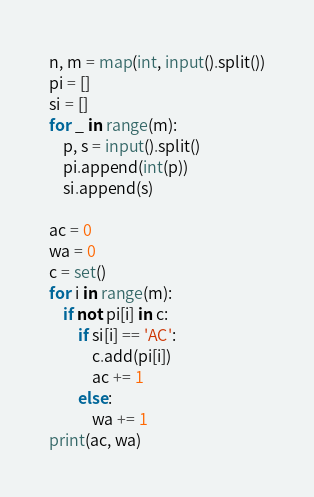<code> <loc_0><loc_0><loc_500><loc_500><_Python_>n, m = map(int, input().split())
pi = []
si = []
for _ in range(m):
    p, s = input().split()
    pi.append(int(p))
    si.append(s)

ac = 0
wa = 0
c = set()
for i in range(m):
    if not pi[i] in c:
        if si[i] == 'AC':
            c.add(pi[i])
            ac += 1
        else:
            wa += 1
print(ac, wa)
</code> 